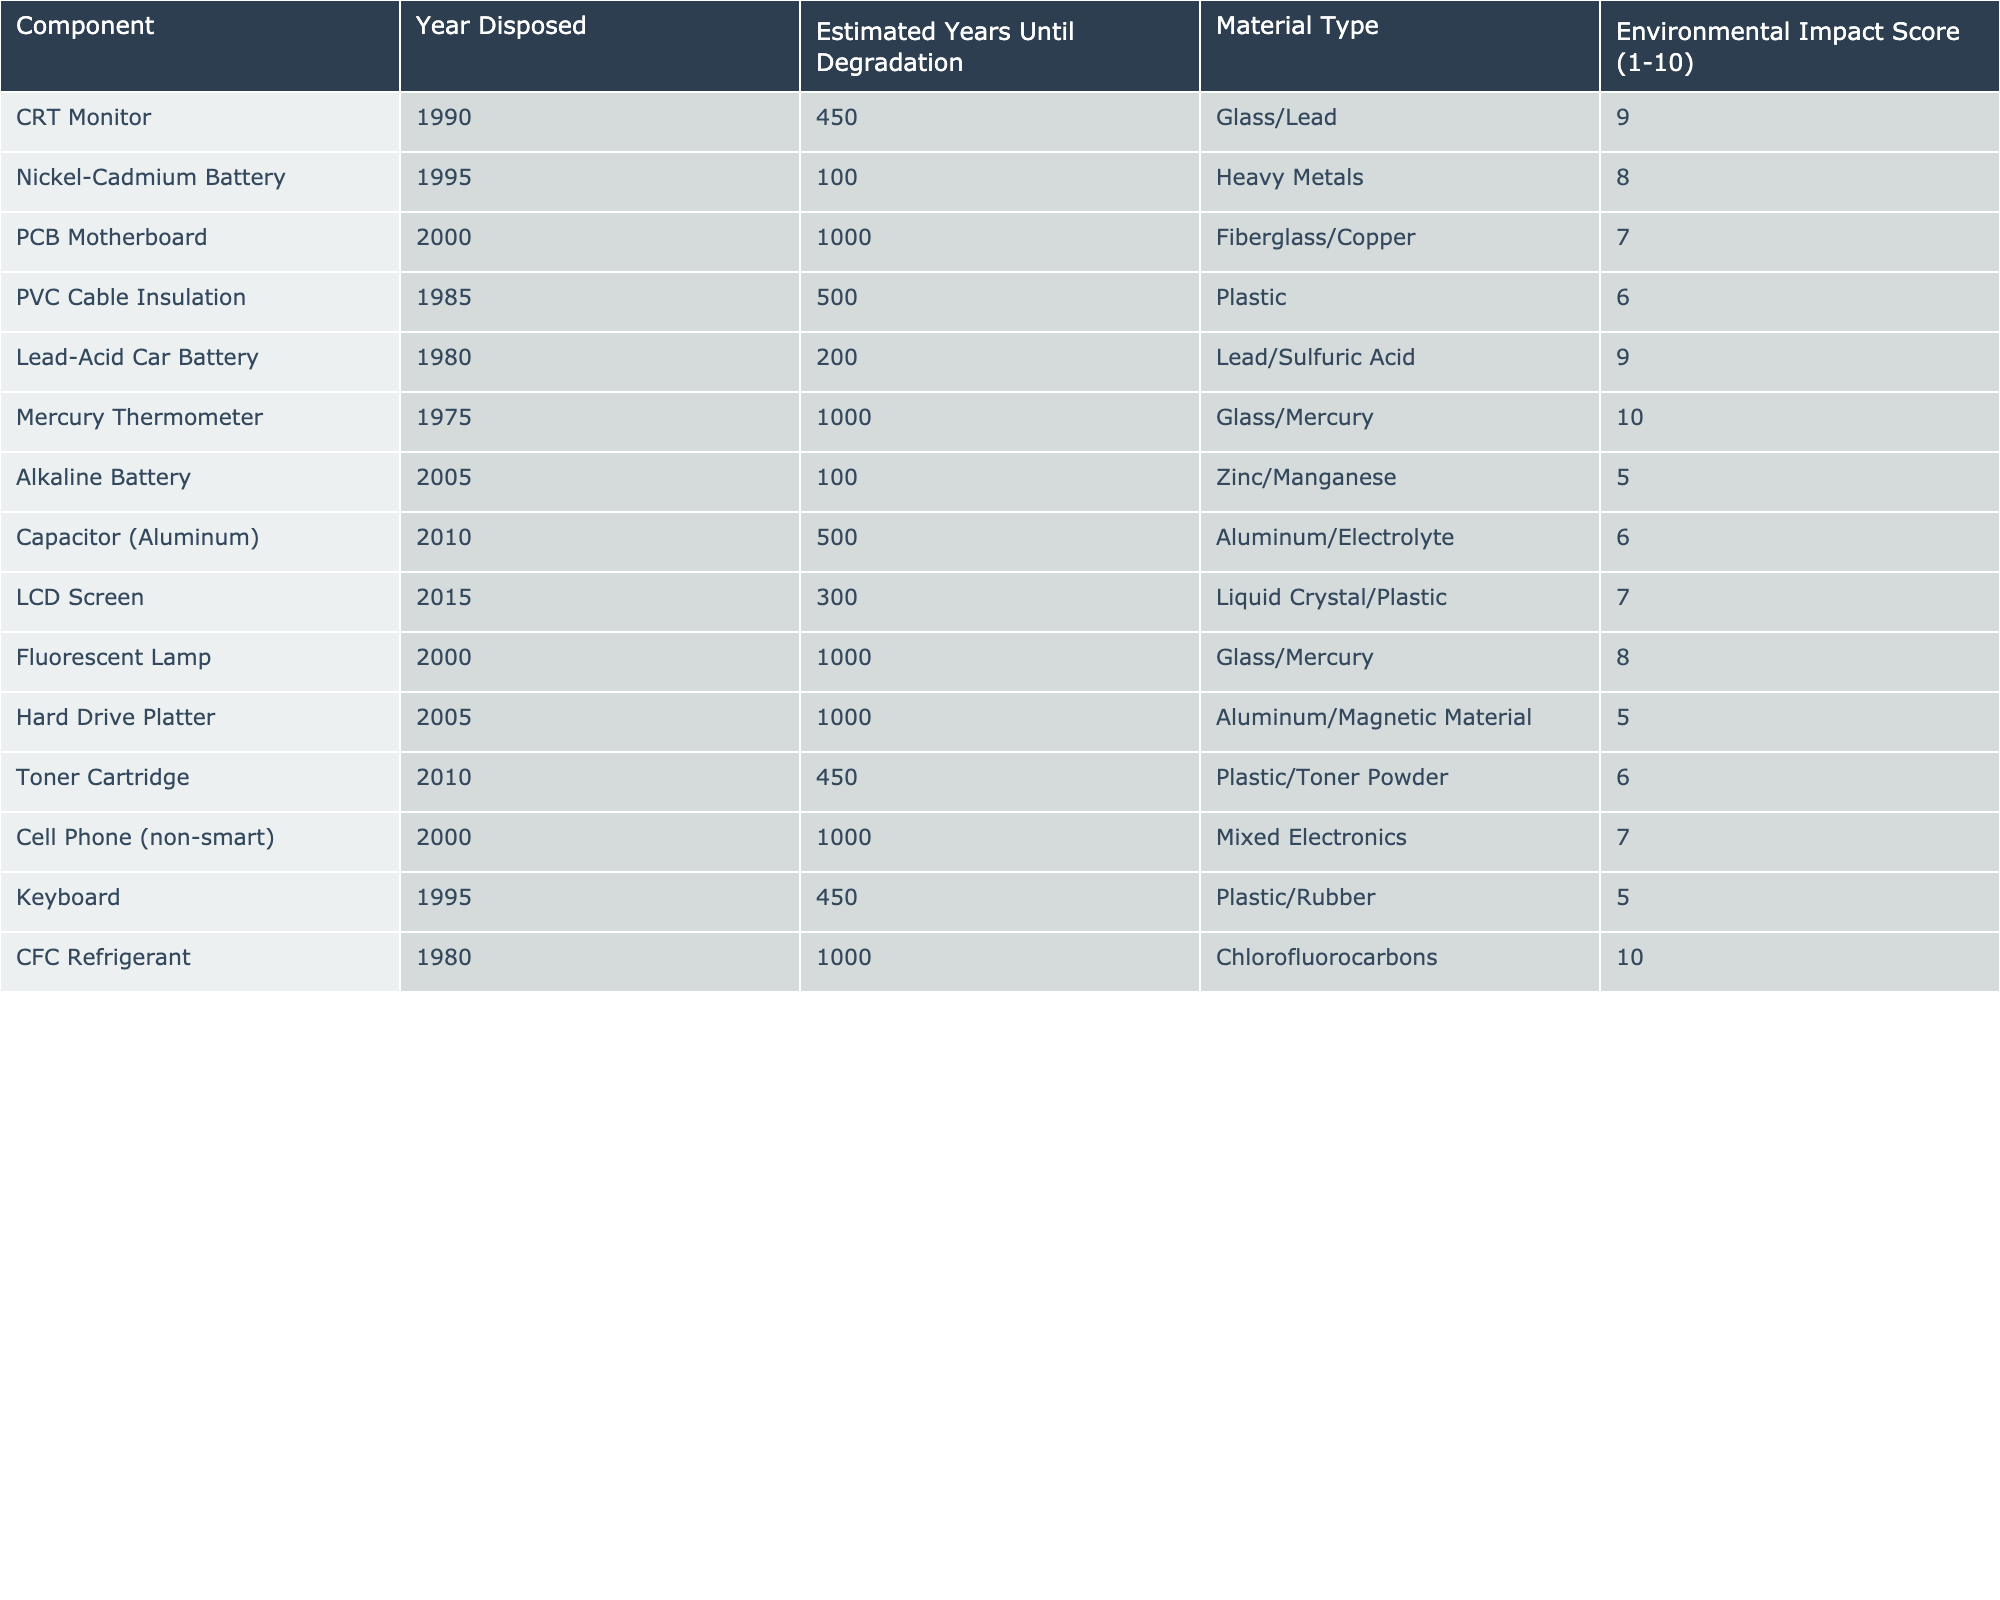What is the estimated lifespan of a CRT Monitor in years? The table directly lists the estimated years until degradation for the CRT Monitor, which is 450 years.
Answer: 450 Which component has the highest Environmental Impact Score? By checking the Environmental Impact Score column, the Mercury Thermometer has the highest score of 10.
Answer: Mercury Thermometer How many components have an estimated lifespan of over 500 years? The components with estimates over 500 years are the CRT Monitor (450), PVC Cable Insulation (500), PCB Motherboard (1000), Mercury Thermometer (1000), Fluorescent Lamp (1000), and CFC Refrigerant (1000). There are a total of five components.
Answer: 5 Is the Alkaline Battery more environmentally friendly than the Toner Cartridge? The Alkaline Battery has an Environmental Impact Score of 5, while the Toner Cartridge has a score of 6. Since 5 is less than 6, the Alkaline Battery is not more environmentally friendly.
Answer: No What is the average Environmental Impact Score of all components listed in the table? The Environmental Impact Scores are 9, 8, 7, 6, 9, 10, 5, 6, 7, 8, 5, 6, 7, 5, 10, which totals to 9 + 8 + 7 + 6 + 9 + 10 + 5 + 6 + 7 + 8 + 5 + 6 + 7 + 5 + 10 = 145. With 15 components, the average score is 145/15 = 9.67.
Answer: 9.67 What is the difference in estimated lifespan between the Lead-Acid Car Battery and the Mercury Thermometer? The estimated lifespan of the Lead-Acid Car Battery is 200 years, and for the Mercury Thermometer, it is 1000 years. The difference is 1000 - 200 = 800 years.
Answer: 800 Which material type has the longest estimated degradation time according to the table? The PCB Motherboard and the Mercury Thermometer both have the highest estimated lifespan of 1000 years and they correspond to the material types Fiberglass/Copper and Glass/Mercury, respectively.
Answer: PCB Motherboard and Mercury Thermometer How many components are made of plastic? The components made of plastic are PVC Cable Insulation, Alkaline Battery, LCD Screen, and Toner Cartridge which totals to four components.
Answer: 4 Is there any component listed with the same degradation estimate? Analyzing the table, the CFC Refrigerant and Mercury Thermometer both have a degradation estimate of 1000 years. Thus, there is a match.
Answer: Yes What is the lifespan of the oldest component on the list? The Lead-Acid Car Battery was disposed of in 1980 and has an estimated degradation time of 200 years. Therefore, its lifecycle ends in 2180.
Answer: 200 years How does the lifespan of the cell phone compare to other components in terms of estimated years until degradation? The Cell Phone has an estimated lifespan of 1000 years, which is similar to the PCB Motherboard, Mercury Thermometer, Fluorescent Lamp, and CFC Refrigerant, all of which exceed 1000 years.
Answer: 1000 years 